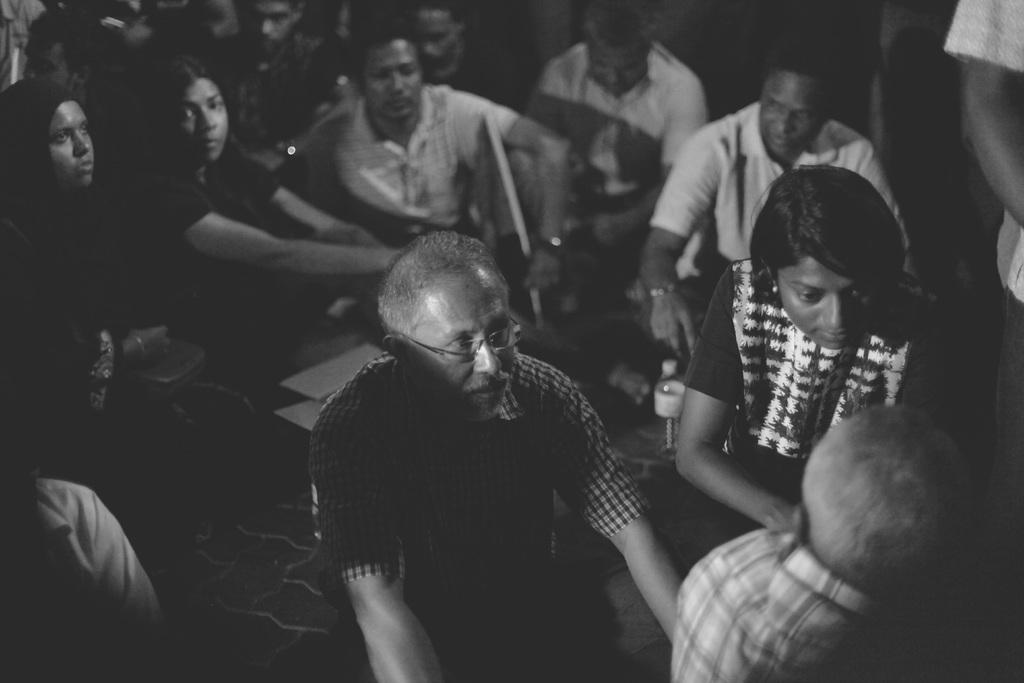What is the color scheme of the image? The image is black and white. What are the people in the image doing? The people are sitting on the floor in the image. What type of cherries can be seen growing in the image? There are no cherries present in the image; it is a black and white image of people sitting on the floor. What direction is the way leading to in the image? There is no way or path visible in the image; it only shows people sitting on the floor. 